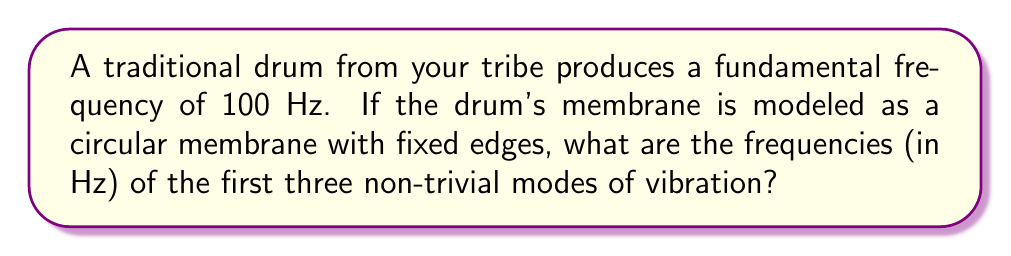Solve this math problem. To solve this problem, we'll follow these steps:

1) For a circular membrane with fixed edges, the eigenfrequencies are given by the formula:

   $$f_{mn} = \frac{c}{2\pi a} \alpha_{mn}$$

   where $c$ is the wave speed, $a$ is the radius of the membrane, and $\alpha_{mn}$ are the zeros of the Bessel function of the first kind.

2) The first few values of $\alpha_{mn}$ are:
   $\alpha_{01} \approx 2.405$
   $\alpha_{11} \approx 3.832$
   $\alpha_{21} \approx 5.136$

3) The fundamental frequency (100 Hz) corresponds to the mode (0,1). So we can set up the equation:

   $$100 = \frac{c}{2\pi a} 2.405$$

4) We don't need to solve for $c$ and $a$ separately. Instead, we can use this equation to find the frequencies of other modes:

   $$f_{mn} = 100 \cdot \frac{\alpha_{mn}}{2.405}$$

5) For the first three non-trivial modes after the fundamental:

   Mode (1,1): $f_{11} = 100 \cdot \frac{3.832}{2.405} \approx 159.33$ Hz
   Mode (2,1): $f_{21} = 100 \cdot \frac{5.136}{2.405} \approx 213.55$ Hz
   Mode (0,2): $f_{02} = 100 \cdot \frac{5.520}{2.405} \approx 229.52$ Hz
Answer: 159.33 Hz, 213.55 Hz, 229.52 Hz 